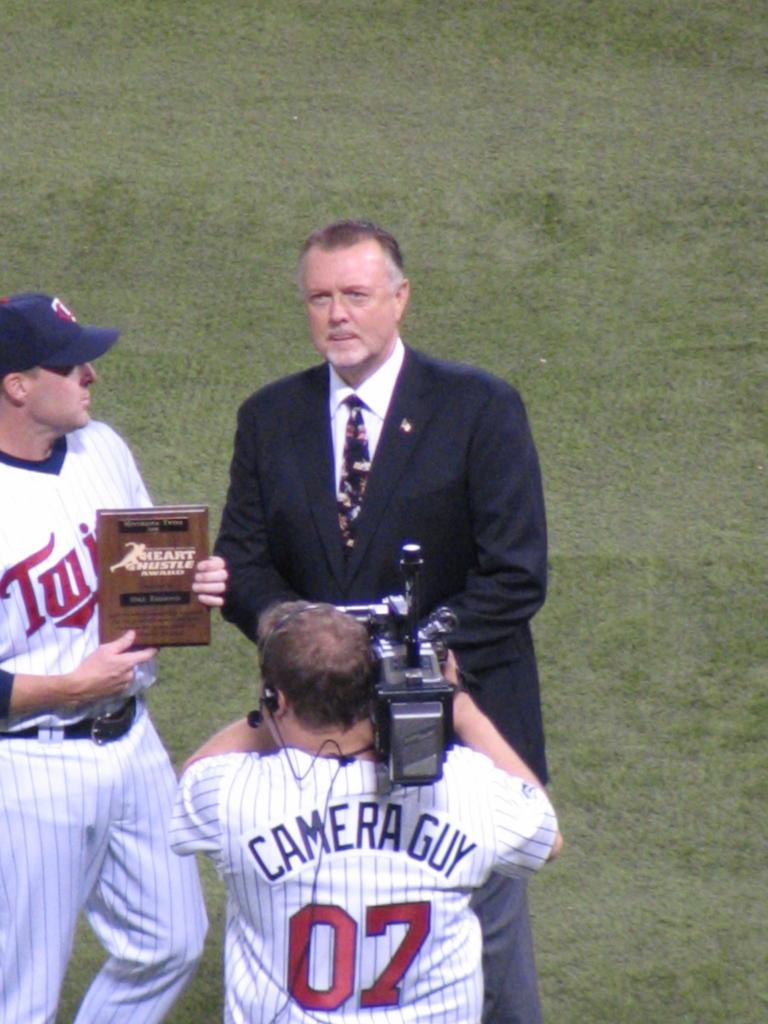<image>
Describe the image concisely. A man wearing a Camera Guy jersey and number 7 films as a Twins player presents an award to a man wearing a suit. 